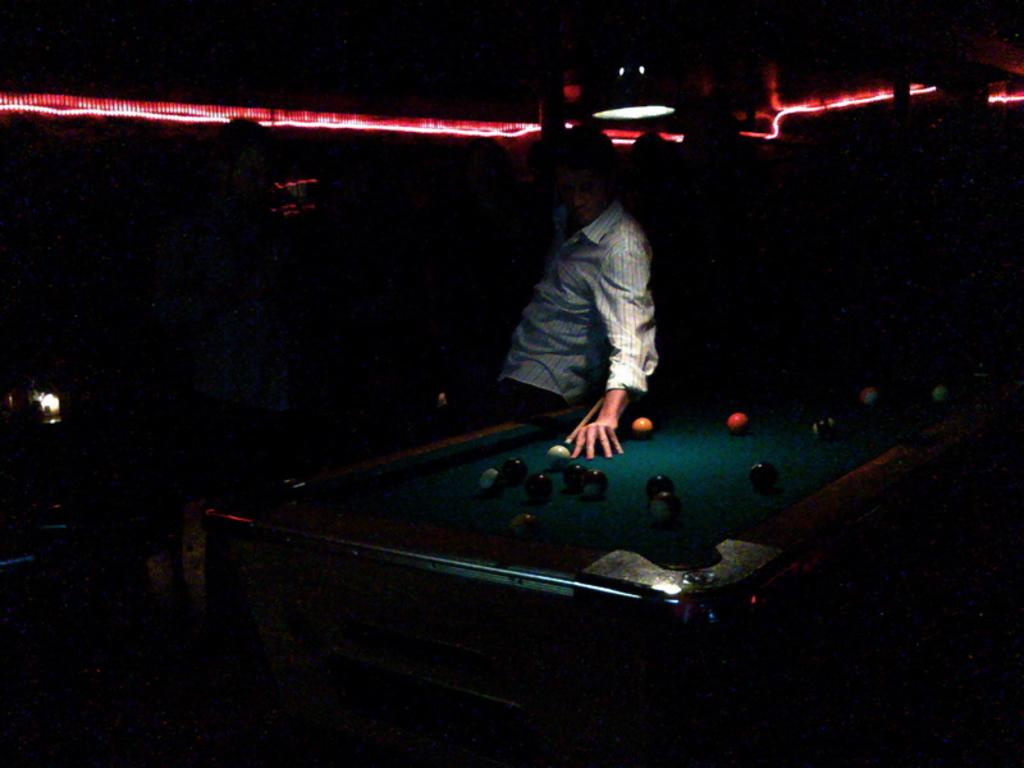What is the main object in the image? There is a snooker table in the image. What is the man in the image doing? A man is playing snooker in the image. How would you describe the lighting in the image? The background of the image is dark. Can you describe any additional lighting in the image? There is a red light at the top of the image. What type of breath can be seen coming from the man's mouth in the image? There is no visible breath coming from the man's mouth in the image. What kind of apparel is the man wearing in the image? The provided facts do not mention the man's apparel, so we cannot determine what he is wearing. --- Facts: 1. There is a car in the image. 2. The car is parked on the street. 3. There are trees on both sides of the street. 4. The sky is visible in the image. 5. The car has a red color. Absurd Topics: bird, ocean, mountain Conversation: What is the main subject of the image? The main subject of the image is a car. Where is the car located in the image? The car is parked on the street. What can be seen on both sides of the street? There are trees on both sides of the street. What is visible in the background of the image? The sky is visible in the image. What color is the car in the image? The car has a red color. Reasoning: Let's think step by step in order to produce the conversation. We start by identifying the main subject of the image, which is the car. Then, we describe the location of the car, noting that it is parked on the street. Next, we focus on the surrounding environment, mentioning the trees on both sides of the street and the visible sky. Finally, we provide information about the car's color, which is red. Absurd Question/Answer: Can you see any birds flying over the ocean in the image? There is no ocean or birds visible in the image; it features include a car, trees, and the sky. Are there any mountains visible in the background of the image? There are no mountains visible in the image; the background consists of trees and the sky. 